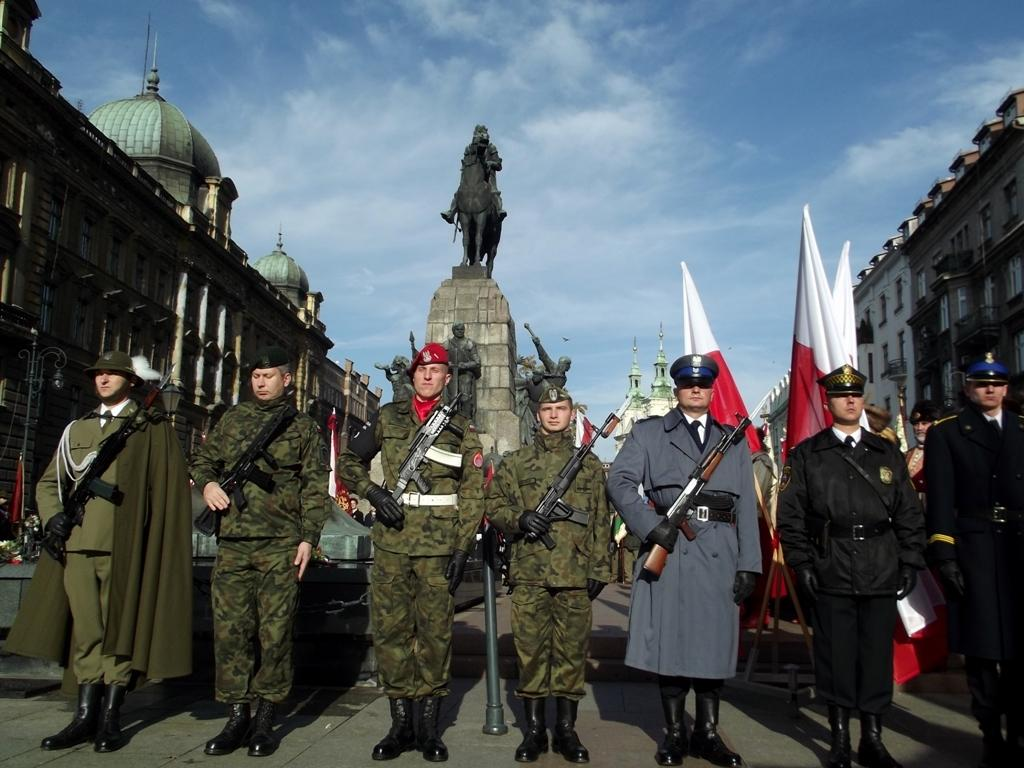What are the people in the image holding? The people in the image are holding guns. What can be seen behind the people? There is a statue behind the people. What other objects are present in the image? There are flags in the image. What can be seen in the background of the image? There are buildings and the sky visible in the background of the image. Where is the queen having lunch in the image? There is no queen or lunchroom present in the image. 